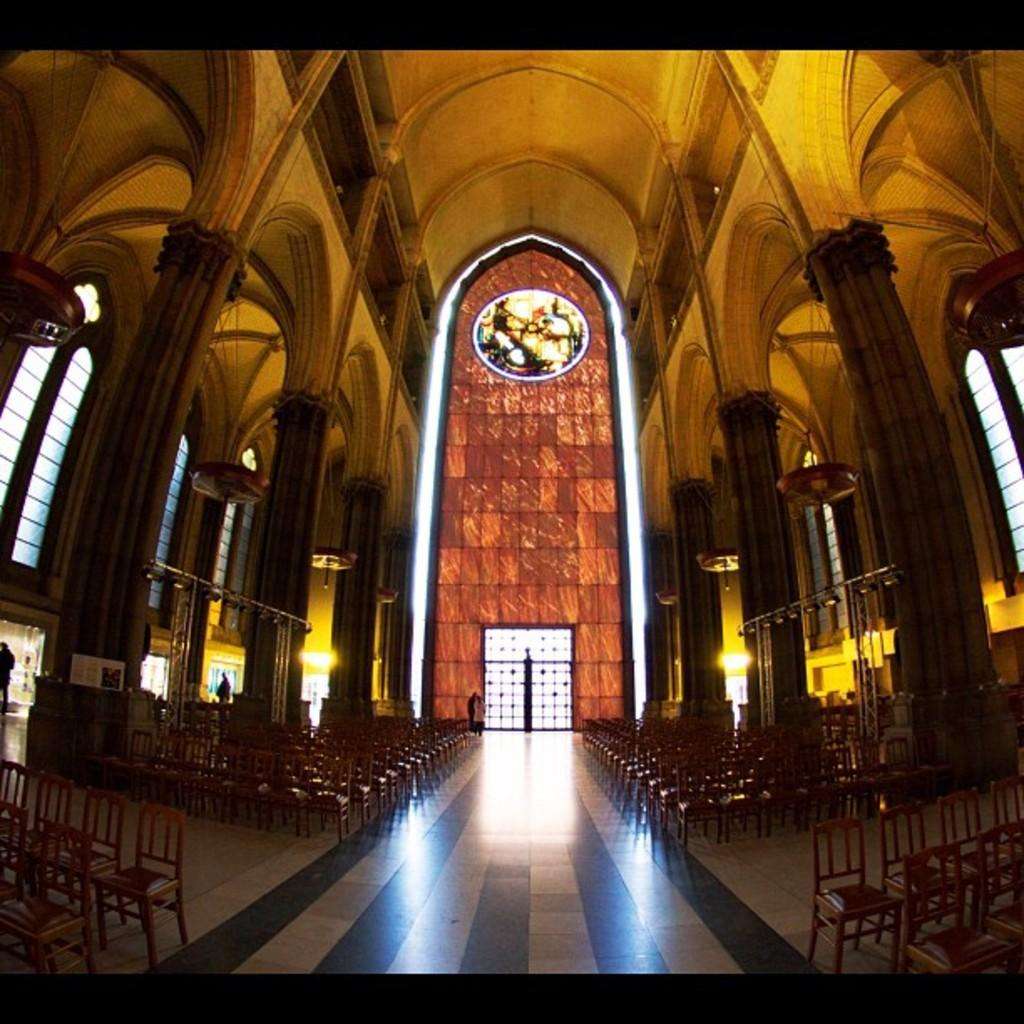What type of building is shown in the image? The image shows the inside view of a church. How are the chairs arranged in the church? Chairs are arranged in the church. What architectural feature can be seen in the church? Pillars are present in the church. What type of dinosaur can be seen in the church in the image? There are no dinosaurs present in the image; it shows the inside view of a church with chairs and pillars. 